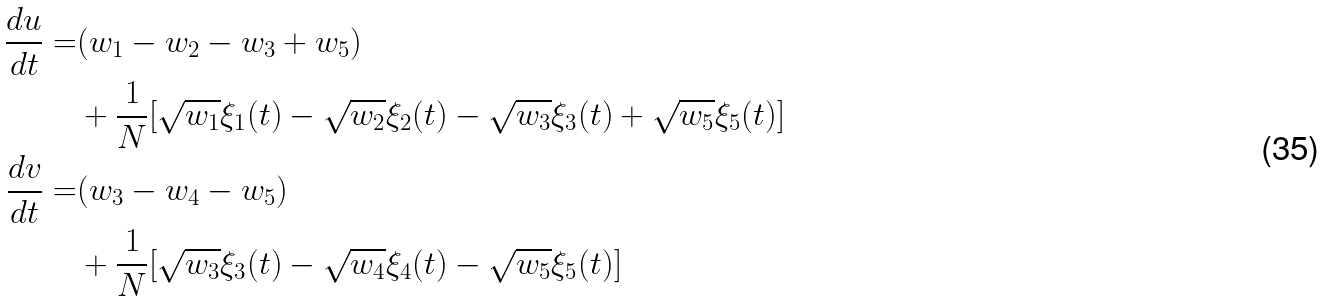<formula> <loc_0><loc_0><loc_500><loc_500>\frac { d u } { d t } = & ( w _ { 1 } - w _ { 2 } - w _ { 3 } + w _ { 5 } ) \\ & + \frac { 1 } { N } [ \sqrt { w _ { 1 } } \xi _ { 1 } ( t ) - \sqrt { w _ { 2 } } \xi _ { 2 } ( t ) - \sqrt { w _ { 3 } } \xi _ { 3 } ( t ) + \sqrt { w _ { 5 } } \xi _ { 5 } ( t ) ] \\ \frac { d v } { d t } = & ( w _ { 3 } - w _ { 4 } - w _ { 5 } ) \\ & + \frac { 1 } { N } [ \sqrt { w _ { 3 } } \xi _ { 3 } ( t ) - \sqrt { w _ { 4 } } \xi _ { 4 } ( t ) - \sqrt { w _ { 5 } } \xi _ { 5 } ( t ) ]</formula> 